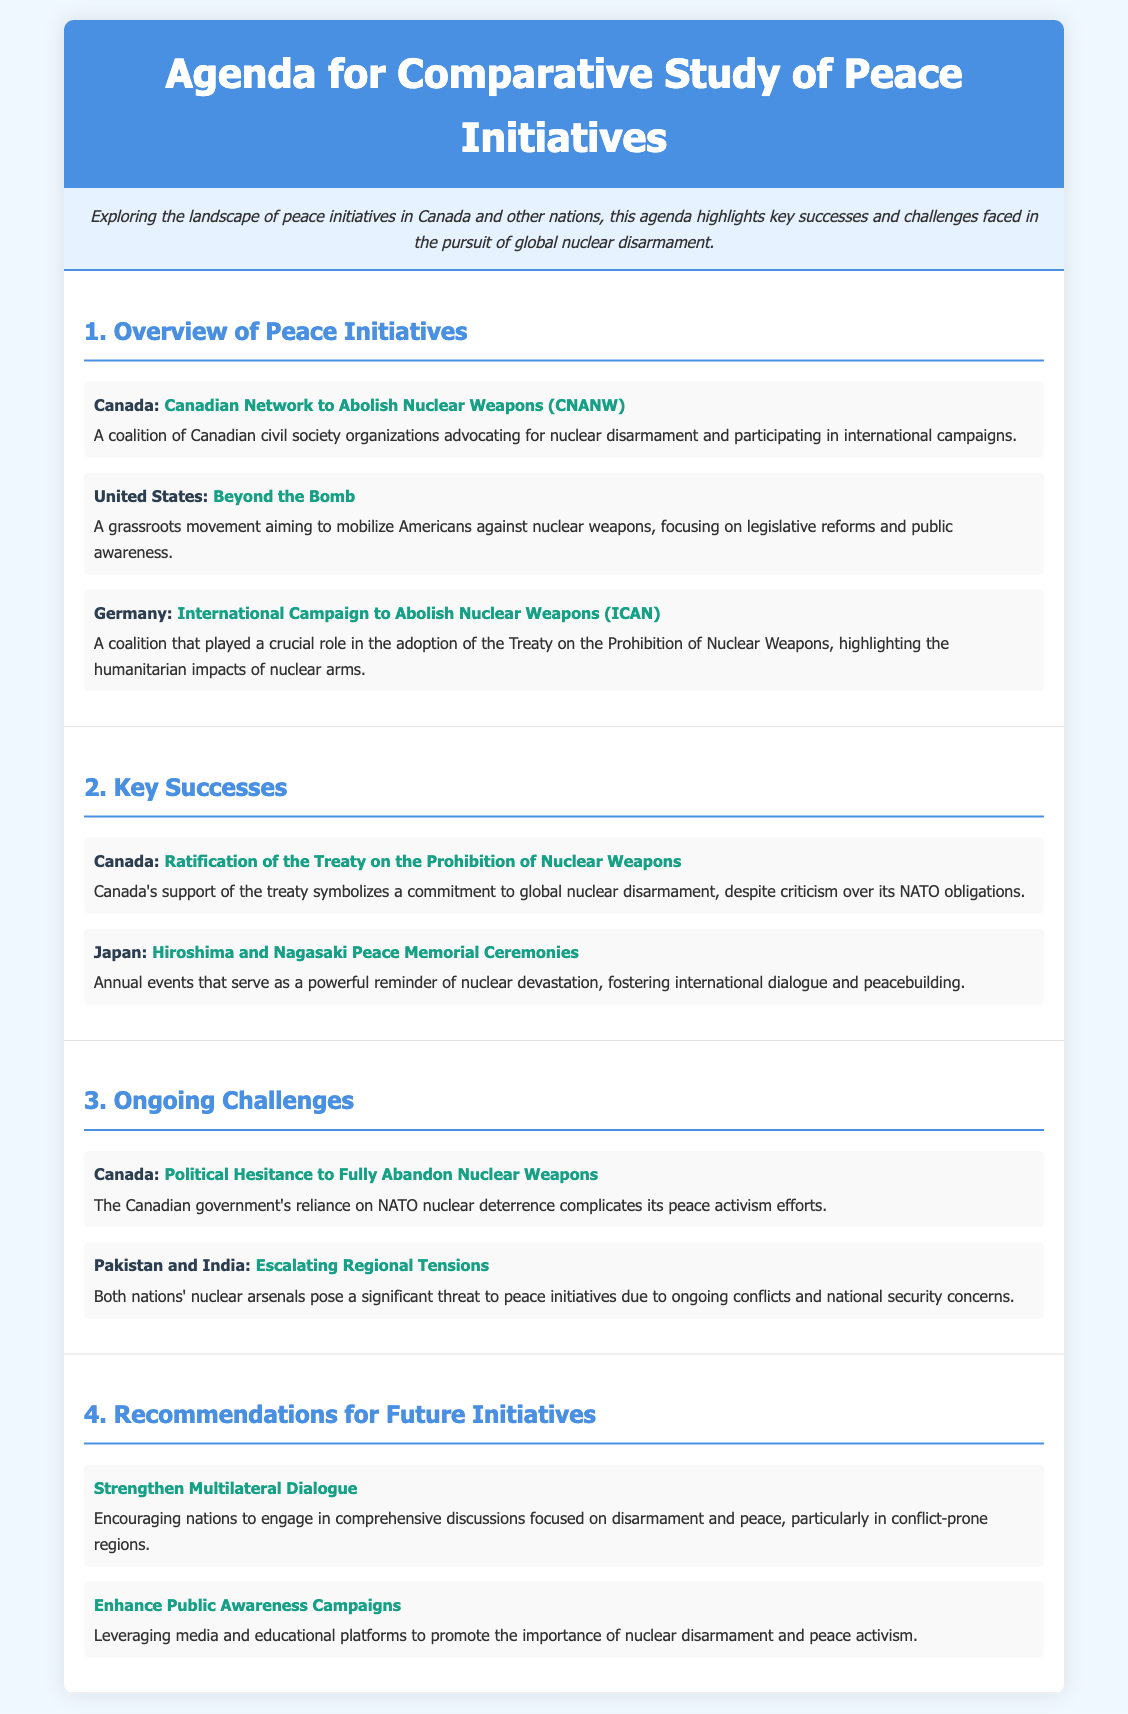What is the title of the agenda? The title of the agenda is prominently displayed at the top of the document, highlighting the main theme of the comparative study.
Answer: Agenda for Comparative Study of Peace Initiatives Which Canadian initiative is mentioned? The document provides a specific initiative from Canada advocating for nuclear disarmament, detailing its role and aim.
Answer: Canadian Network to Abolish Nuclear Weapons (CNANW) What successful event is highlighted from Japan? This event is highlighted within the key successes section, emphasizing its importance in fostering dialogue around nuclear devastation.
Answer: Hiroshima and Nagasaki Peace Memorial Ceremonies Which challenge does Canada face regarding nuclear weapons? The challenges section lists specific issues Canada encounters with its nuclear policies and political commitments.
Answer: Political Hesitance to Fully Abandon Nuclear Weapons What is a recommended strategy for future initiatives? The recommendations section offers strategies for enhancing peace initiatives, focusing on multilateral efforts and public involvement.
Answer: Strengthen Multilateral Dialogue 